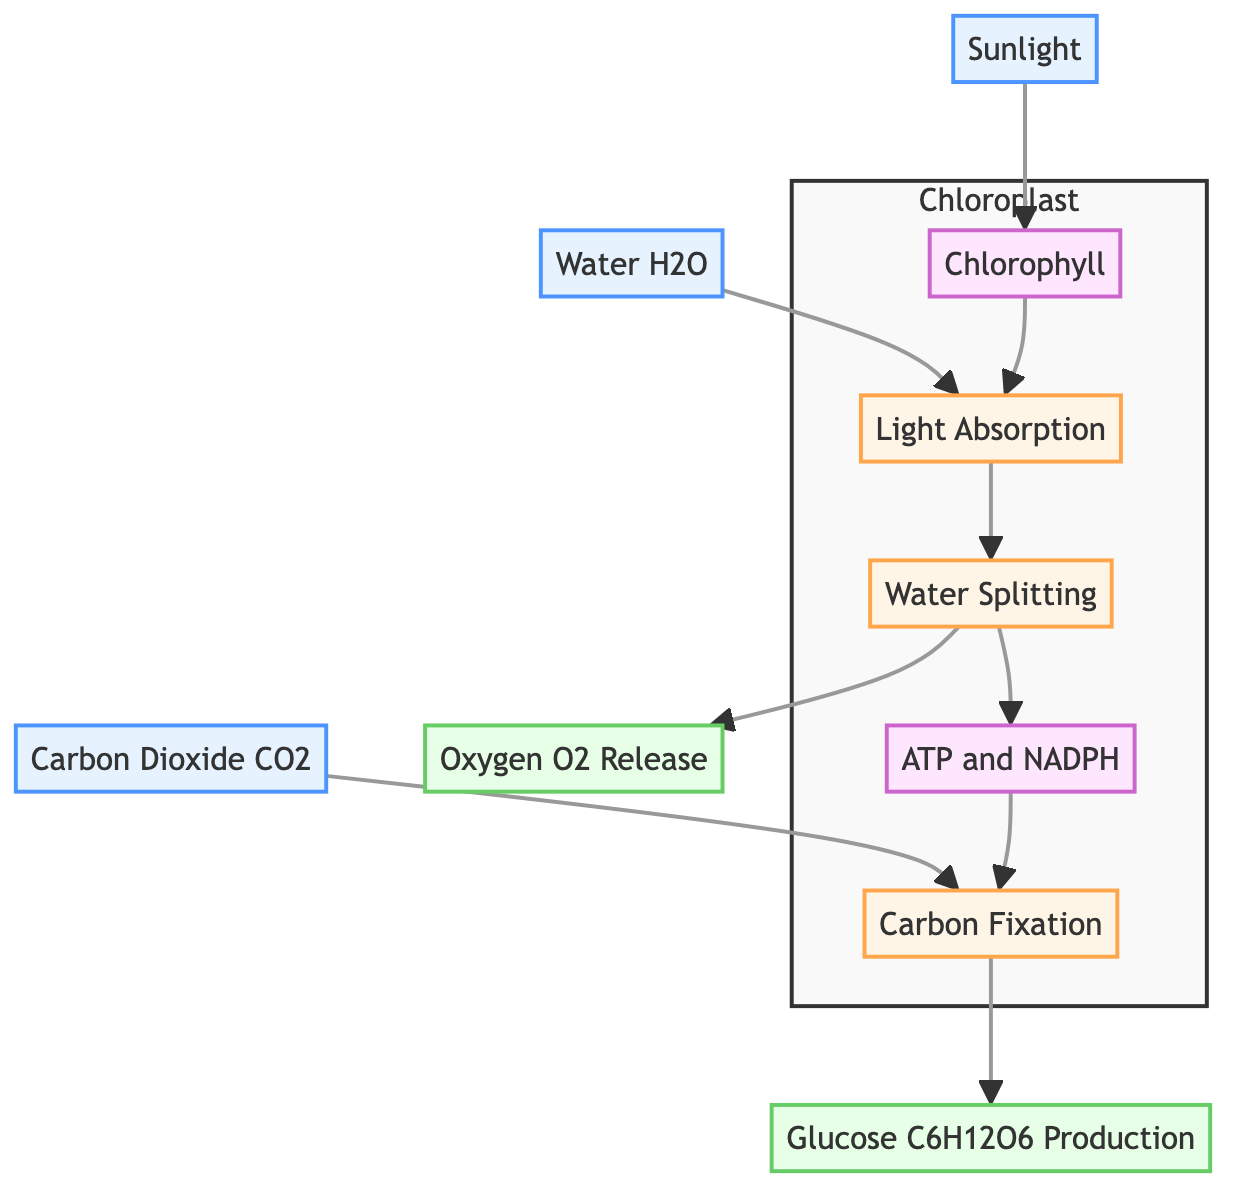What is the energy source required for photosynthesis? The diagram indicates that the energy source for photosynthesis is represented by the node labeled "Sunlight."
Answer: Sunlight Which molecule absorbs light energy in the photosynthesis process? According to the diagram, the node "Chlorophyll" is the molecule responsible for absorbing light energy during photosynthesis.
Answer: Chlorophyll What is produced as a byproduct from splitting water? The diagram shows that the node labeled "Oxygen O2 Release" outputs oxygen as a byproduct of the water-splitting process.
Answer: Oxygen O2 Release How many inputs are there in the diagram? The diagram identifies three input nodes: "Sunlight," "Water (H2O)," and "Carbon Dioxide (CO2)." Therefore, there are three inputs present.
Answer: 3 Which process combines carbon dioxide with other molecules? The diagram indicates that the "Carbon Fixation" process is responsible for combining carbon dioxide with other molecules to form carbohydrates.
Answer: Carbon Fixation What role does ATP and NADPH play in the photosynthesis process? The diagram indicates that "ATP and NADPH" are energy carriers produced during the light-dependent reactions and are used in the Calvin cycle.
Answer: Energy carriers What is the output of the photosynthesis process? The last output in the diagram is the node labeled "Glucose C6H12O6 Production," indicating that glucose is the final product of photosynthesis.
Answer: Glucose C6H12O6 Production What process occurs after light absorption? Following "Light Absorption," the diagram shows the "Water Splitting" process, indicating the sequence of events in photosynthesis.
Answer: Water Splitting In which organelle does photosynthesis occur? The diagram specifies that photosynthesis takes place within the "Chloroplast," as illustrated by the highlighted organelle section.
Answer: Chloroplast 